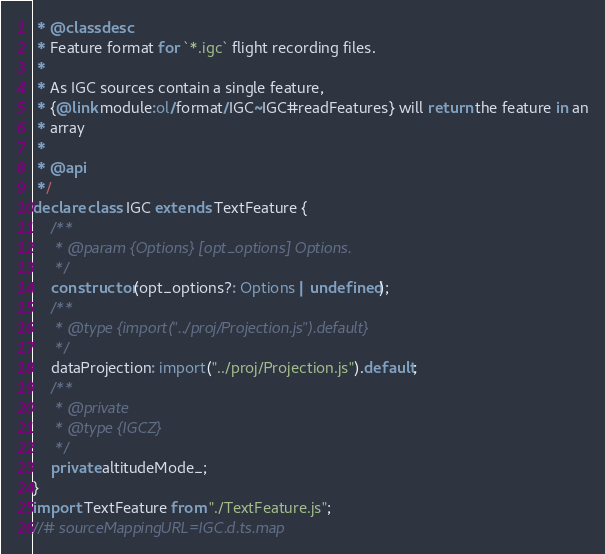<code> <loc_0><loc_0><loc_500><loc_500><_TypeScript_> * @classdesc
 * Feature format for `*.igc` flight recording files.
 *
 * As IGC sources contain a single feature,
 * {@link module:ol/format/IGC~IGC#readFeatures} will return the feature in an
 * array
 *
 * @api
 */
declare class IGC extends TextFeature {
    /**
     * @param {Options} [opt_options] Options.
     */
    constructor(opt_options?: Options | undefined);
    /**
     * @type {import("../proj/Projection.js").default}
     */
    dataProjection: import("../proj/Projection.js").default;
    /**
     * @private
     * @type {IGCZ}
     */
    private altitudeMode_;
}
import TextFeature from "./TextFeature.js";
//# sourceMappingURL=IGC.d.ts.map</code> 